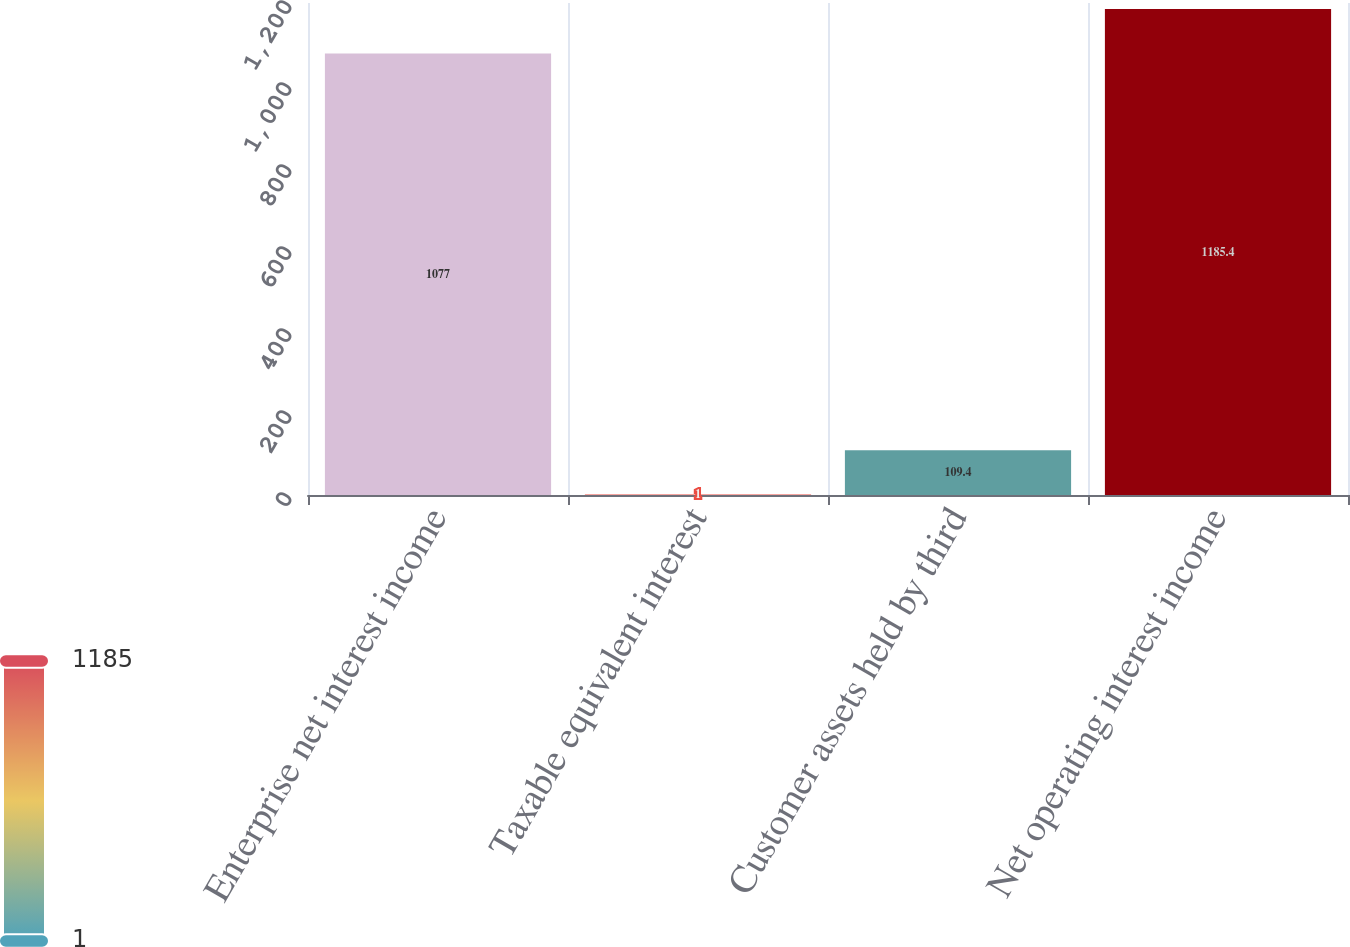Convert chart to OTSL. <chart><loc_0><loc_0><loc_500><loc_500><bar_chart><fcel>Enterprise net interest income<fcel>Taxable equivalent interest<fcel>Customer assets held by third<fcel>Net operating interest income<nl><fcel>1077<fcel>1<fcel>109.4<fcel>1185.4<nl></chart> 